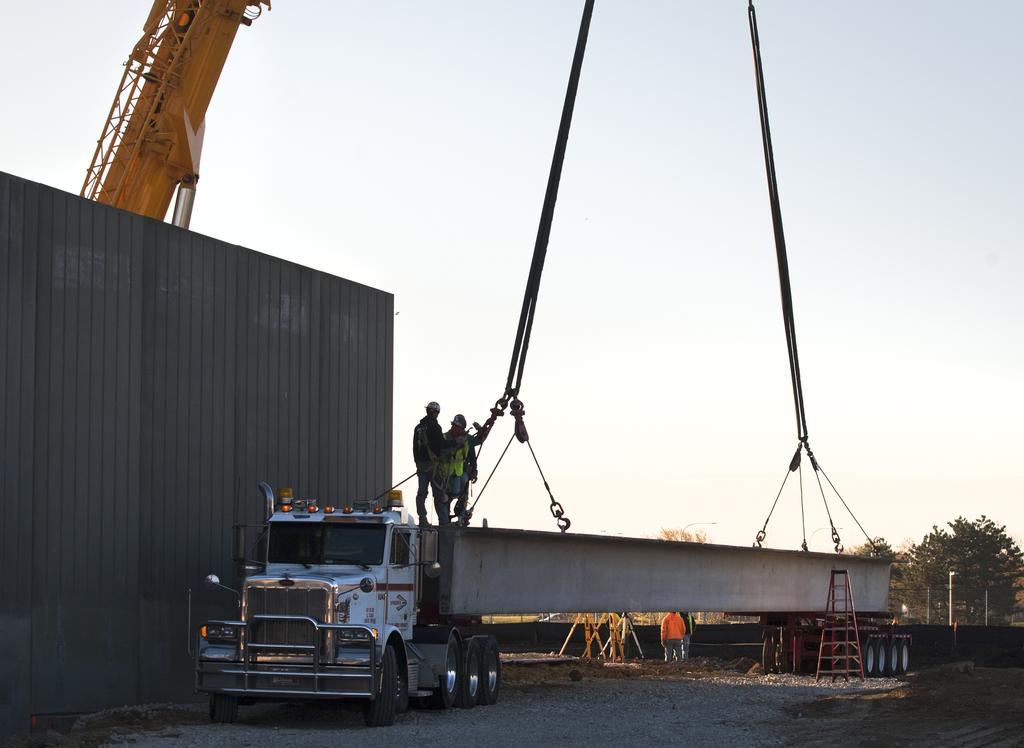What type of machinery is present in the image? There is a crane in the image. Are there any human figures in the image? Yes, there are people in the image. What material is visible in the image? There is a metal sheet in the image. What type of natural environment is present in the image? There are trees in the image. What is visible in the background of the image? The sky is visible in the image. What type of pen is being used by the people in the image? There is no pen present in the image; it features a crane, people, a metal sheet, trees, and the sky. 